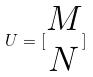Convert formula to latex. <formula><loc_0><loc_0><loc_500><loc_500>U = [ \begin{matrix} M \\ N \end{matrix} ]</formula> 